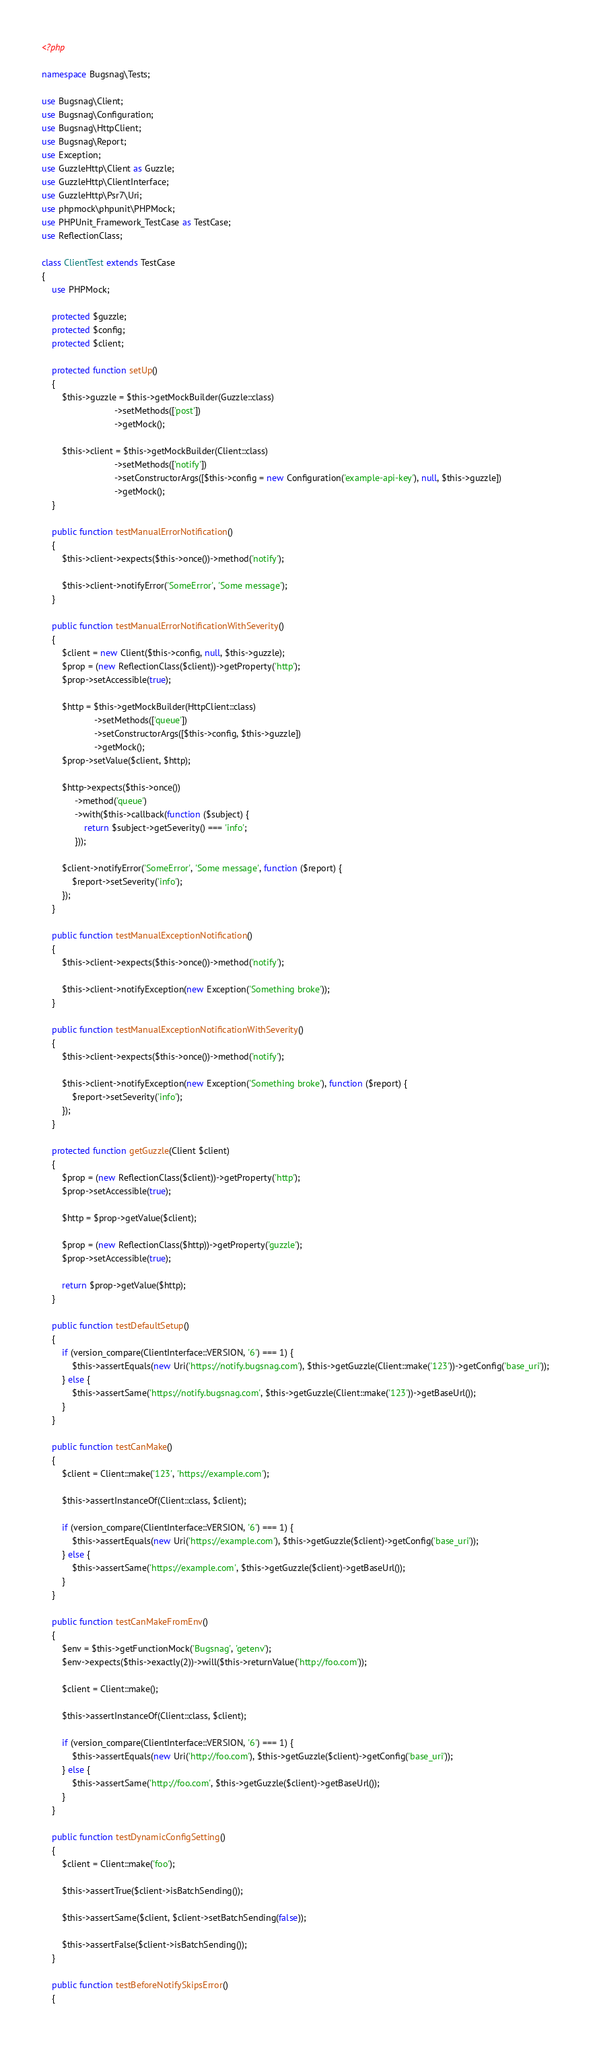<code> <loc_0><loc_0><loc_500><loc_500><_PHP_><?php

namespace Bugsnag\Tests;

use Bugsnag\Client;
use Bugsnag\Configuration;
use Bugsnag\HttpClient;
use Bugsnag\Report;
use Exception;
use GuzzleHttp\Client as Guzzle;
use GuzzleHttp\ClientInterface;
use GuzzleHttp\Psr7\Uri;
use phpmock\phpunit\PHPMock;
use PHPUnit_Framework_TestCase as TestCase;
use ReflectionClass;

class ClientTest extends TestCase
{
    use PHPMock;

    protected $guzzle;
    protected $config;
    protected $client;

    protected function setUp()
    {
        $this->guzzle = $this->getMockBuilder(Guzzle::class)
                             ->setMethods(['post'])
                             ->getMock();

        $this->client = $this->getMockBuilder(Client::class)
                             ->setMethods(['notify'])
                             ->setConstructorArgs([$this->config = new Configuration('example-api-key'), null, $this->guzzle])
                             ->getMock();
    }

    public function testManualErrorNotification()
    {
        $this->client->expects($this->once())->method('notify');

        $this->client->notifyError('SomeError', 'Some message');
    }

    public function testManualErrorNotificationWithSeverity()
    {
        $client = new Client($this->config, null, $this->guzzle);
        $prop = (new ReflectionClass($client))->getProperty('http');
        $prop->setAccessible(true);

        $http = $this->getMockBuilder(HttpClient::class)
                     ->setMethods(['queue'])
                     ->setConstructorArgs([$this->config, $this->guzzle])
                     ->getMock();
        $prop->setValue($client, $http);

        $http->expects($this->once())
             ->method('queue')
             ->with($this->callback(function ($subject) {
                 return $subject->getSeverity() === 'info';
             }));

        $client->notifyError('SomeError', 'Some message', function ($report) {
            $report->setSeverity('info');
        });
    }

    public function testManualExceptionNotification()
    {
        $this->client->expects($this->once())->method('notify');

        $this->client->notifyException(new Exception('Something broke'));
    }

    public function testManualExceptionNotificationWithSeverity()
    {
        $this->client->expects($this->once())->method('notify');

        $this->client->notifyException(new Exception('Something broke'), function ($report) {
            $report->setSeverity('info');
        });
    }

    protected function getGuzzle(Client $client)
    {
        $prop = (new ReflectionClass($client))->getProperty('http');
        $prop->setAccessible(true);

        $http = $prop->getValue($client);

        $prop = (new ReflectionClass($http))->getProperty('guzzle');
        $prop->setAccessible(true);

        return $prop->getValue($http);
    }

    public function testDefaultSetup()
    {
        if (version_compare(ClientInterface::VERSION, '6') === 1) {
            $this->assertEquals(new Uri('https://notify.bugsnag.com'), $this->getGuzzle(Client::make('123'))->getConfig('base_uri'));
        } else {
            $this->assertSame('https://notify.bugsnag.com', $this->getGuzzle(Client::make('123'))->getBaseUrl());
        }
    }

    public function testCanMake()
    {
        $client = Client::make('123', 'https://example.com');

        $this->assertInstanceOf(Client::class, $client);

        if (version_compare(ClientInterface::VERSION, '6') === 1) {
            $this->assertEquals(new Uri('https://example.com'), $this->getGuzzle($client)->getConfig('base_uri'));
        } else {
            $this->assertSame('https://example.com', $this->getGuzzle($client)->getBaseUrl());
        }
    }

    public function testCanMakeFromEnv()
    {
        $env = $this->getFunctionMock('Bugsnag', 'getenv');
        $env->expects($this->exactly(2))->will($this->returnValue('http://foo.com'));

        $client = Client::make();

        $this->assertInstanceOf(Client::class, $client);

        if (version_compare(ClientInterface::VERSION, '6') === 1) {
            $this->assertEquals(new Uri('http://foo.com'), $this->getGuzzle($client)->getConfig('base_uri'));
        } else {
            $this->assertSame('http://foo.com', $this->getGuzzle($client)->getBaseUrl());
        }
    }

    public function testDynamicConfigSetting()
    {
        $client = Client::make('foo');

        $this->assertTrue($client->isBatchSending());

        $this->assertSame($client, $client->setBatchSending(false));

        $this->assertFalse($client->isBatchSending());
    }

    public function testBeforeNotifySkipsError()
    {</code> 